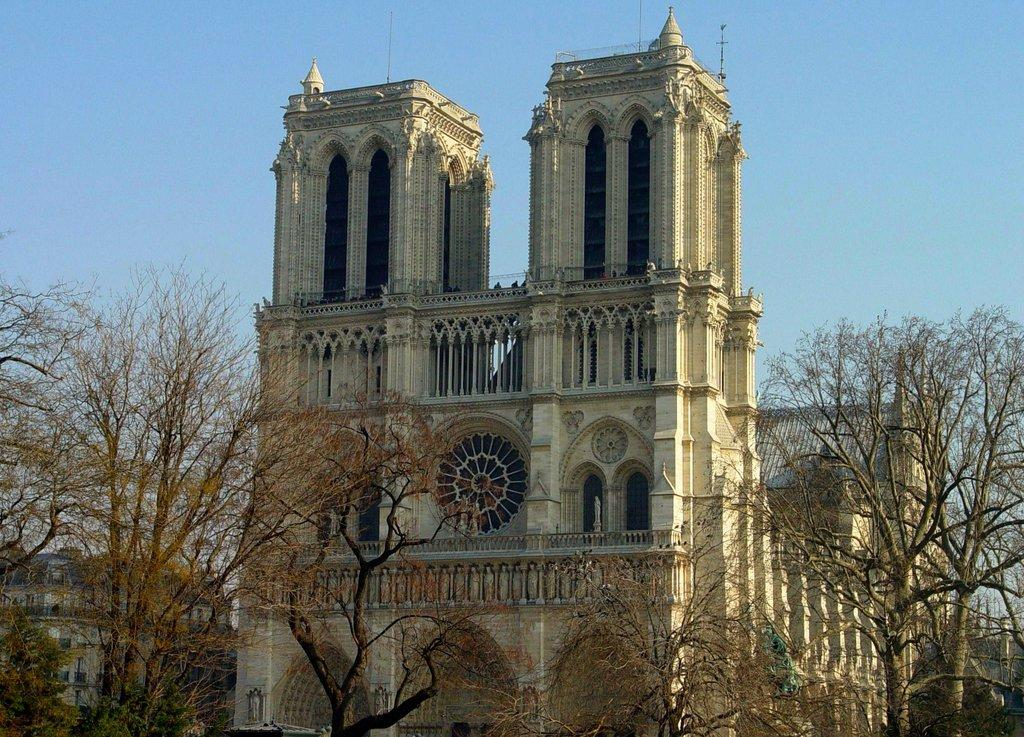What type of structure is visible in the image? There is a building in the image. What can be seen in front of the building? Trees are present in front of the building. What is visible above the building? The sky is visible above the building. How many yaks can be seen grazing in front of the building? There are no yaks present in the image; only trees can be seen in front of the building. 